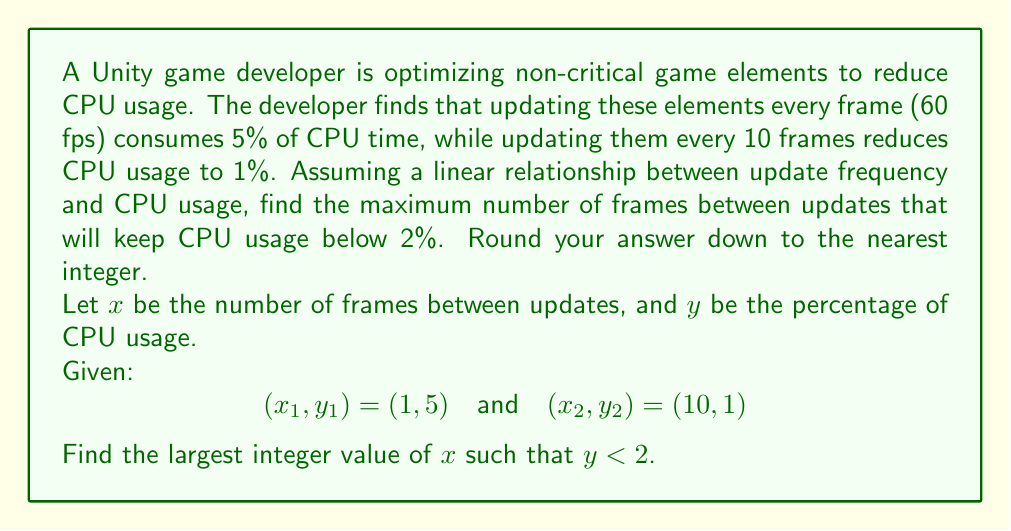Teach me how to tackle this problem. 1) First, we need to find the linear equation relating $x$ and $y$. We can use the point-slope form:

   $$y - y_1 = m(x - x_1)$$

2) Calculate the slope $m$:
   $$m = \frac{y_2 - y_1}{x_2 - x_1} = \frac{1 - 5}{10 - 1} = -\frac{4}{9}$$

3) Use the point $(1, 5)$ to find the equation:
   $$y - 5 = -\frac{4}{9}(x - 1)$$

4) Simplify:
   $$y = -\frac{4}{9}x + \frac{49}{9}$$

5) We want to find $x$ when $y < 2$:
   $$2 > -\frac{4}{9}x + \frac{49}{9}$$

6) Solve for $x$:
   $$-\frac{31}{9} > -\frac{4}{9}x$$
   $$\frac{31}{4} < x$$

7) The largest integer value of $x$ that satisfies this inequality is 7.

Therefore, the maximum number of frames between updates to keep CPU usage below 2% is 7 frames.
Answer: 7 frames 